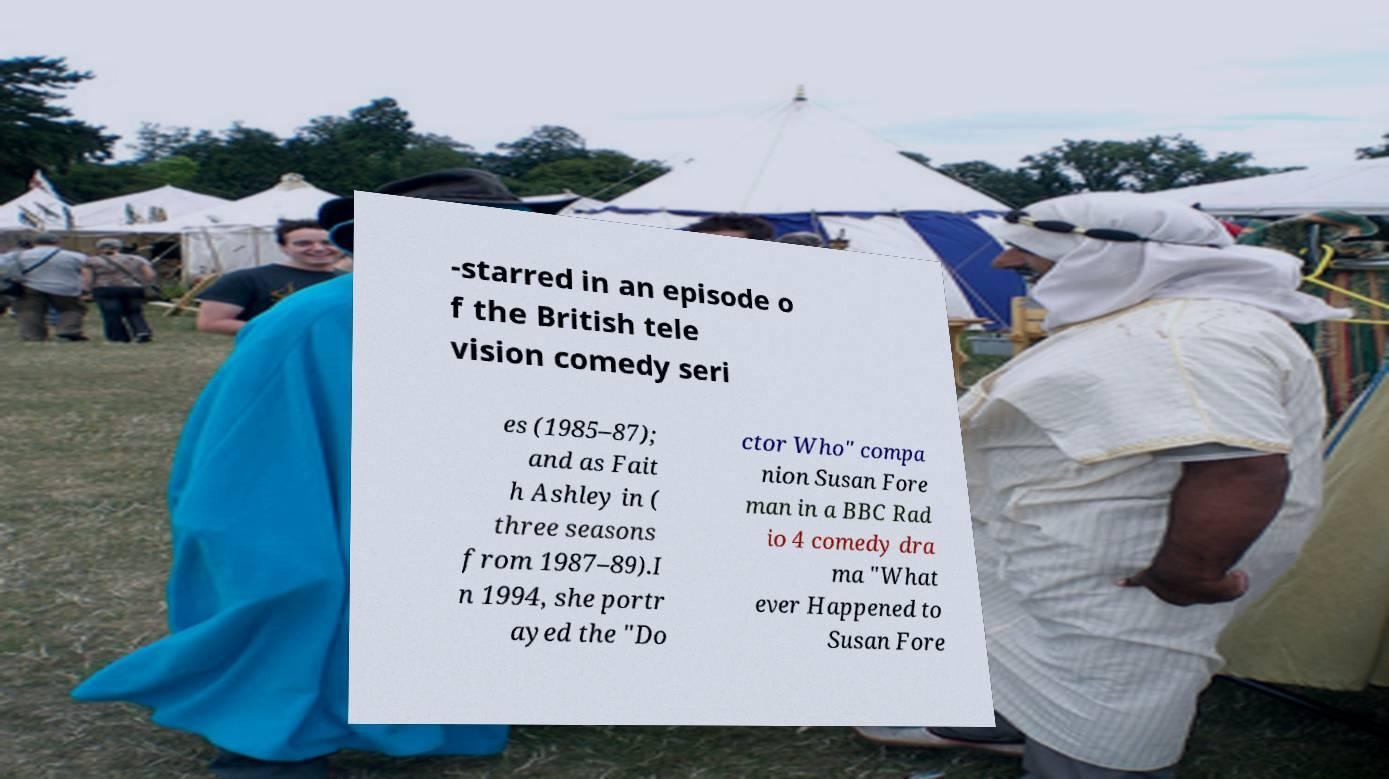Could you assist in decoding the text presented in this image and type it out clearly? -starred in an episode o f the British tele vision comedy seri es (1985–87); and as Fait h Ashley in ( three seasons from 1987–89).I n 1994, she portr ayed the "Do ctor Who" compa nion Susan Fore man in a BBC Rad io 4 comedy dra ma "What ever Happened to Susan Fore 